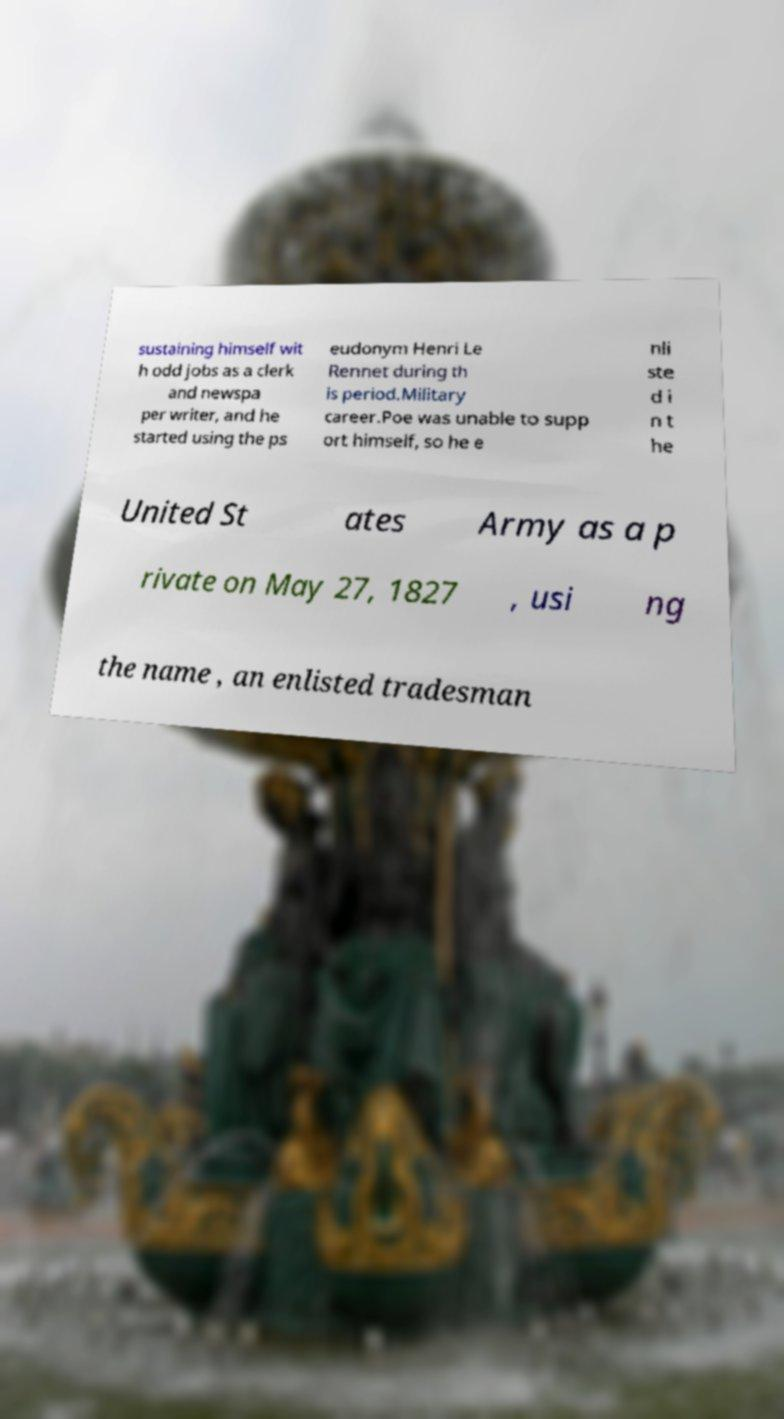For documentation purposes, I need the text within this image transcribed. Could you provide that? sustaining himself wit h odd jobs as a clerk and newspa per writer, and he started using the ps eudonym Henri Le Rennet during th is period.Military career.Poe was unable to supp ort himself, so he e nli ste d i n t he United St ates Army as a p rivate on May 27, 1827 , usi ng the name , an enlisted tradesman 